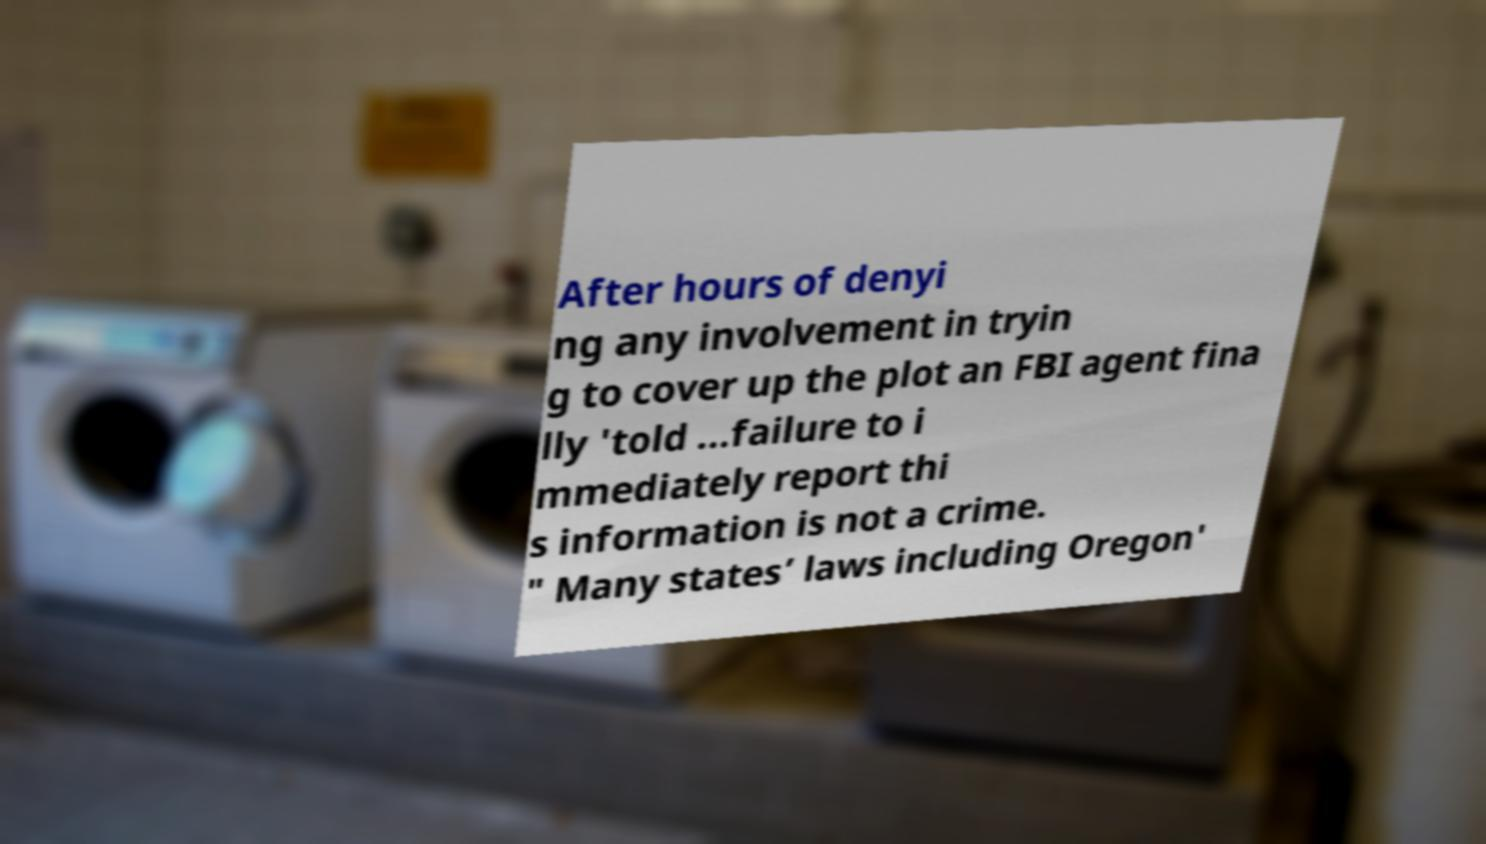For documentation purposes, I need the text within this image transcribed. Could you provide that? After hours of denyi ng any involvement in tryin g to cover up the plot an FBI agent fina lly 'told ...failure to i mmediately report thi s information is not a crime. " Many states’ laws including Oregon' 